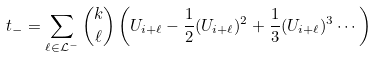<formula> <loc_0><loc_0><loc_500><loc_500>t _ { - } = \sum _ { \ell \in \mathcal { L } ^ { - } } \binom { k } { \ell } \left ( U _ { i + \ell } - \frac { 1 } { 2 } ( U _ { i + \ell } ) ^ { 2 } + \frac { 1 } { 3 } ( U _ { i + \ell } ) ^ { 3 } \cdots \right )</formula> 